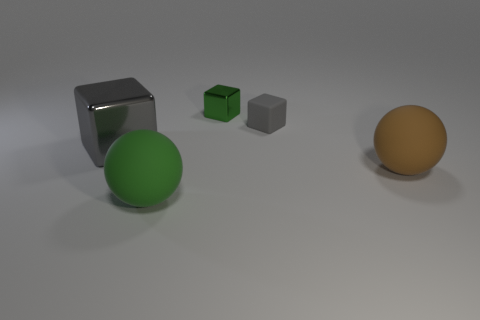Subtract all green blocks. How many blocks are left? 2 Subtract all small green metal cubes. How many cubes are left? 2 Add 3 gray cubes. How many gray cubes are left? 5 Add 5 tiny blue things. How many tiny blue things exist? 5 Add 4 yellow matte things. How many objects exist? 9 Subtract 0 purple cylinders. How many objects are left? 5 Subtract all cubes. How many objects are left? 2 Subtract 1 balls. How many balls are left? 1 Subtract all brown balls. Subtract all red cubes. How many balls are left? 1 Subtract all yellow cylinders. How many cyan balls are left? 0 